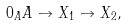Convert formula to latex. <formula><loc_0><loc_0><loc_500><loc_500>0 _ { A } A \to X _ { 1 } \to X _ { 2 } ,</formula> 